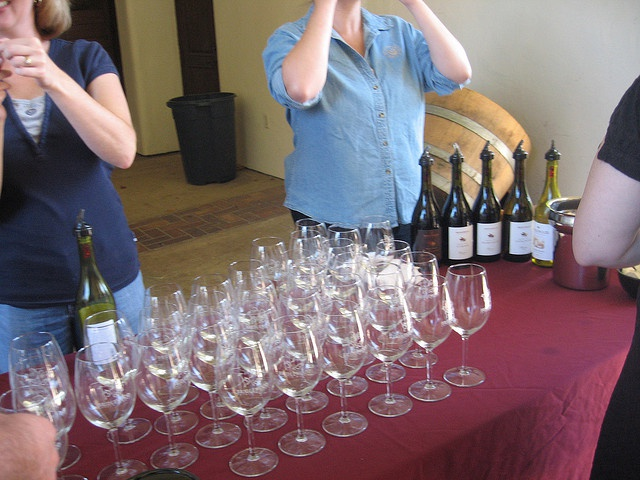Describe the objects in this image and their specific colors. I can see people in brown, black, navy, lightpink, and pink tones, dining table in brown and maroon tones, people in brown, gray, lightblue, and darkgray tones, wine glass in brown, darkgray, gray, and lightgray tones, and people in brown, black, darkgray, and gray tones in this image. 